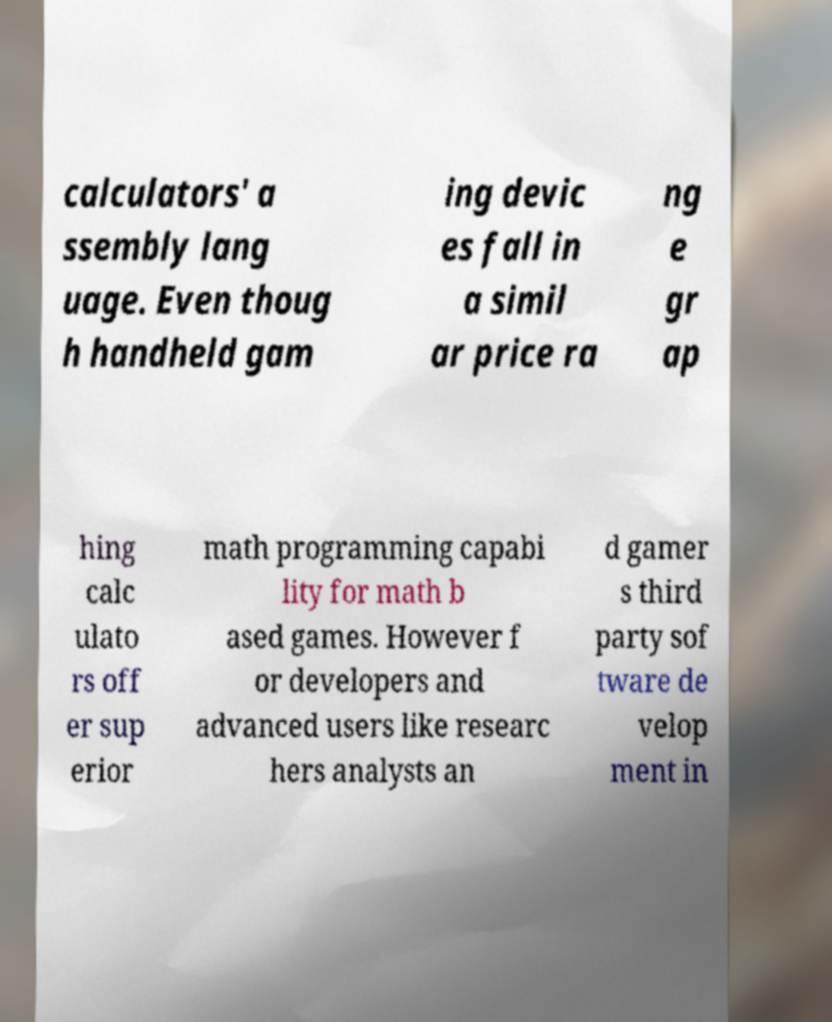For documentation purposes, I need the text within this image transcribed. Could you provide that? calculators' a ssembly lang uage. Even thoug h handheld gam ing devic es fall in a simil ar price ra ng e gr ap hing calc ulato rs off er sup erior math programming capabi lity for math b ased games. However f or developers and advanced users like researc hers analysts an d gamer s third party sof tware de velop ment in 